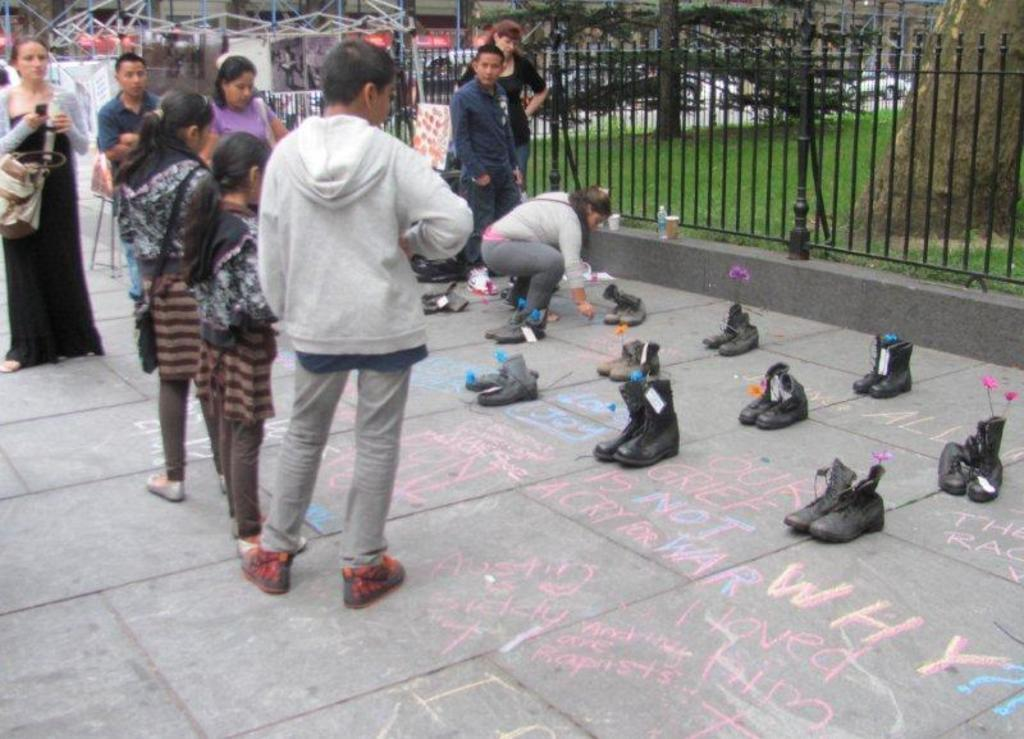How many people are in the image? There is a group of persons standing in the image. What can be seen on the road in the image? There are pairs of shoes with tags on the road. What type of architectural feature is present in the image? There are iron grills in the image. What type of vegetation is present in the image? There are plants and grass in the image. What type of container is present in the image? There is a bottle in the image. What type of tableware is present in the image? There are glasses in the image. What type of structures are present in the image? There are buildings in the image. What type of transportation is present in the image? There is a vehicle in the image. Where is the station located in the image? There is no station present in the image. What type of ship can be seen in the image? There is no ship present in the image. What type of cleaning tool is used by the plants in the image? Plants do not use cleaning tools like sponges; they absorb water and nutrients through their roots. 